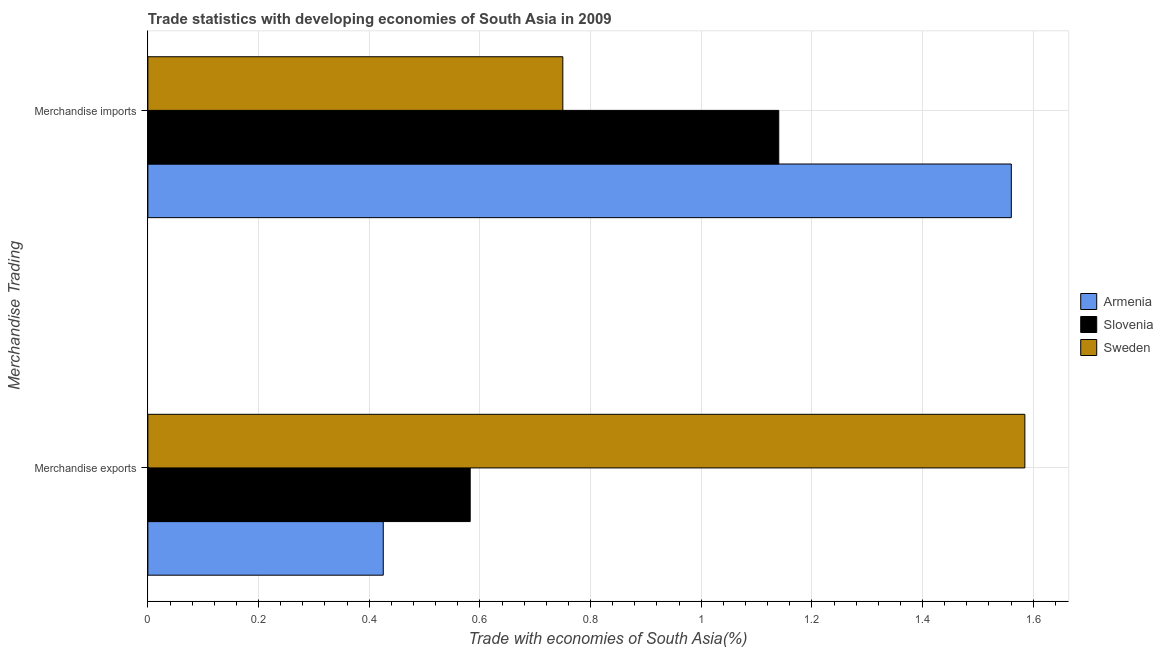How many different coloured bars are there?
Offer a very short reply. 3. How many groups of bars are there?
Your response must be concise. 2. Are the number of bars per tick equal to the number of legend labels?
Make the answer very short. Yes. How many bars are there on the 2nd tick from the top?
Offer a very short reply. 3. How many bars are there on the 1st tick from the bottom?
Ensure brevity in your answer.  3. What is the label of the 2nd group of bars from the top?
Offer a very short reply. Merchandise exports. What is the merchandise imports in Slovenia?
Your answer should be very brief. 1.14. Across all countries, what is the maximum merchandise exports?
Your answer should be compact. 1.58. Across all countries, what is the minimum merchandise imports?
Your answer should be compact. 0.75. In which country was the merchandise exports maximum?
Provide a succinct answer. Sweden. In which country was the merchandise exports minimum?
Offer a very short reply. Armenia. What is the total merchandise exports in the graph?
Your answer should be very brief. 2.59. What is the difference between the merchandise exports in Sweden and that in Slovenia?
Give a very brief answer. 1. What is the difference between the merchandise imports in Sweden and the merchandise exports in Armenia?
Make the answer very short. 0.32. What is the average merchandise exports per country?
Your answer should be compact. 0.86. What is the difference between the merchandise exports and merchandise imports in Sweden?
Provide a short and direct response. 0.83. In how many countries, is the merchandise exports greater than 0.9600000000000001 %?
Ensure brevity in your answer.  1. What is the ratio of the merchandise exports in Sweden to that in Armenia?
Give a very brief answer. 3.73. Is the merchandise imports in Sweden less than that in Armenia?
Ensure brevity in your answer.  Yes. What does the 3rd bar from the top in Merchandise imports represents?
Your response must be concise. Armenia. What does the 2nd bar from the bottom in Merchandise imports represents?
Make the answer very short. Slovenia. Are all the bars in the graph horizontal?
Make the answer very short. Yes. Are the values on the major ticks of X-axis written in scientific E-notation?
Keep it short and to the point. No. Does the graph contain any zero values?
Offer a terse response. No. Where does the legend appear in the graph?
Provide a short and direct response. Center right. How many legend labels are there?
Offer a terse response. 3. How are the legend labels stacked?
Your answer should be very brief. Vertical. What is the title of the graph?
Your answer should be compact. Trade statistics with developing economies of South Asia in 2009. Does "Kenya" appear as one of the legend labels in the graph?
Make the answer very short. No. What is the label or title of the X-axis?
Make the answer very short. Trade with economies of South Asia(%). What is the label or title of the Y-axis?
Make the answer very short. Merchandise Trading. What is the Trade with economies of South Asia(%) in Armenia in Merchandise exports?
Your response must be concise. 0.43. What is the Trade with economies of South Asia(%) in Slovenia in Merchandise exports?
Offer a terse response. 0.58. What is the Trade with economies of South Asia(%) of Sweden in Merchandise exports?
Your answer should be very brief. 1.58. What is the Trade with economies of South Asia(%) in Armenia in Merchandise imports?
Give a very brief answer. 1.56. What is the Trade with economies of South Asia(%) in Slovenia in Merchandise imports?
Make the answer very short. 1.14. What is the Trade with economies of South Asia(%) of Sweden in Merchandise imports?
Your response must be concise. 0.75. Across all Merchandise Trading, what is the maximum Trade with economies of South Asia(%) of Armenia?
Provide a short and direct response. 1.56. Across all Merchandise Trading, what is the maximum Trade with economies of South Asia(%) in Slovenia?
Ensure brevity in your answer.  1.14. Across all Merchandise Trading, what is the maximum Trade with economies of South Asia(%) of Sweden?
Ensure brevity in your answer.  1.58. Across all Merchandise Trading, what is the minimum Trade with economies of South Asia(%) in Armenia?
Your answer should be very brief. 0.43. Across all Merchandise Trading, what is the minimum Trade with economies of South Asia(%) in Slovenia?
Give a very brief answer. 0.58. Across all Merchandise Trading, what is the minimum Trade with economies of South Asia(%) in Sweden?
Provide a succinct answer. 0.75. What is the total Trade with economies of South Asia(%) in Armenia in the graph?
Ensure brevity in your answer.  1.99. What is the total Trade with economies of South Asia(%) in Slovenia in the graph?
Your answer should be compact. 1.72. What is the total Trade with economies of South Asia(%) in Sweden in the graph?
Keep it short and to the point. 2.33. What is the difference between the Trade with economies of South Asia(%) in Armenia in Merchandise exports and that in Merchandise imports?
Your answer should be very brief. -1.14. What is the difference between the Trade with economies of South Asia(%) in Slovenia in Merchandise exports and that in Merchandise imports?
Make the answer very short. -0.56. What is the difference between the Trade with economies of South Asia(%) in Sweden in Merchandise exports and that in Merchandise imports?
Your response must be concise. 0.83. What is the difference between the Trade with economies of South Asia(%) of Armenia in Merchandise exports and the Trade with economies of South Asia(%) of Slovenia in Merchandise imports?
Your response must be concise. -0.71. What is the difference between the Trade with economies of South Asia(%) of Armenia in Merchandise exports and the Trade with economies of South Asia(%) of Sweden in Merchandise imports?
Your answer should be compact. -0.32. What is the difference between the Trade with economies of South Asia(%) of Slovenia in Merchandise exports and the Trade with economies of South Asia(%) of Sweden in Merchandise imports?
Provide a short and direct response. -0.17. What is the average Trade with economies of South Asia(%) of Armenia per Merchandise Trading?
Your response must be concise. 0.99. What is the average Trade with economies of South Asia(%) in Slovenia per Merchandise Trading?
Offer a terse response. 0.86. What is the average Trade with economies of South Asia(%) in Sweden per Merchandise Trading?
Provide a short and direct response. 1.17. What is the difference between the Trade with economies of South Asia(%) in Armenia and Trade with economies of South Asia(%) in Slovenia in Merchandise exports?
Your answer should be very brief. -0.16. What is the difference between the Trade with economies of South Asia(%) of Armenia and Trade with economies of South Asia(%) of Sweden in Merchandise exports?
Make the answer very short. -1.16. What is the difference between the Trade with economies of South Asia(%) in Slovenia and Trade with economies of South Asia(%) in Sweden in Merchandise exports?
Offer a terse response. -1. What is the difference between the Trade with economies of South Asia(%) of Armenia and Trade with economies of South Asia(%) of Slovenia in Merchandise imports?
Offer a very short reply. 0.42. What is the difference between the Trade with economies of South Asia(%) of Armenia and Trade with economies of South Asia(%) of Sweden in Merchandise imports?
Your answer should be compact. 0.81. What is the difference between the Trade with economies of South Asia(%) in Slovenia and Trade with economies of South Asia(%) in Sweden in Merchandise imports?
Provide a short and direct response. 0.39. What is the ratio of the Trade with economies of South Asia(%) of Armenia in Merchandise exports to that in Merchandise imports?
Your response must be concise. 0.27. What is the ratio of the Trade with economies of South Asia(%) in Slovenia in Merchandise exports to that in Merchandise imports?
Ensure brevity in your answer.  0.51. What is the ratio of the Trade with economies of South Asia(%) of Sweden in Merchandise exports to that in Merchandise imports?
Provide a short and direct response. 2.11. What is the difference between the highest and the second highest Trade with economies of South Asia(%) in Armenia?
Make the answer very short. 1.14. What is the difference between the highest and the second highest Trade with economies of South Asia(%) of Slovenia?
Offer a very short reply. 0.56. What is the difference between the highest and the second highest Trade with economies of South Asia(%) of Sweden?
Your response must be concise. 0.83. What is the difference between the highest and the lowest Trade with economies of South Asia(%) of Armenia?
Your response must be concise. 1.14. What is the difference between the highest and the lowest Trade with economies of South Asia(%) of Slovenia?
Your response must be concise. 0.56. What is the difference between the highest and the lowest Trade with economies of South Asia(%) of Sweden?
Keep it short and to the point. 0.83. 